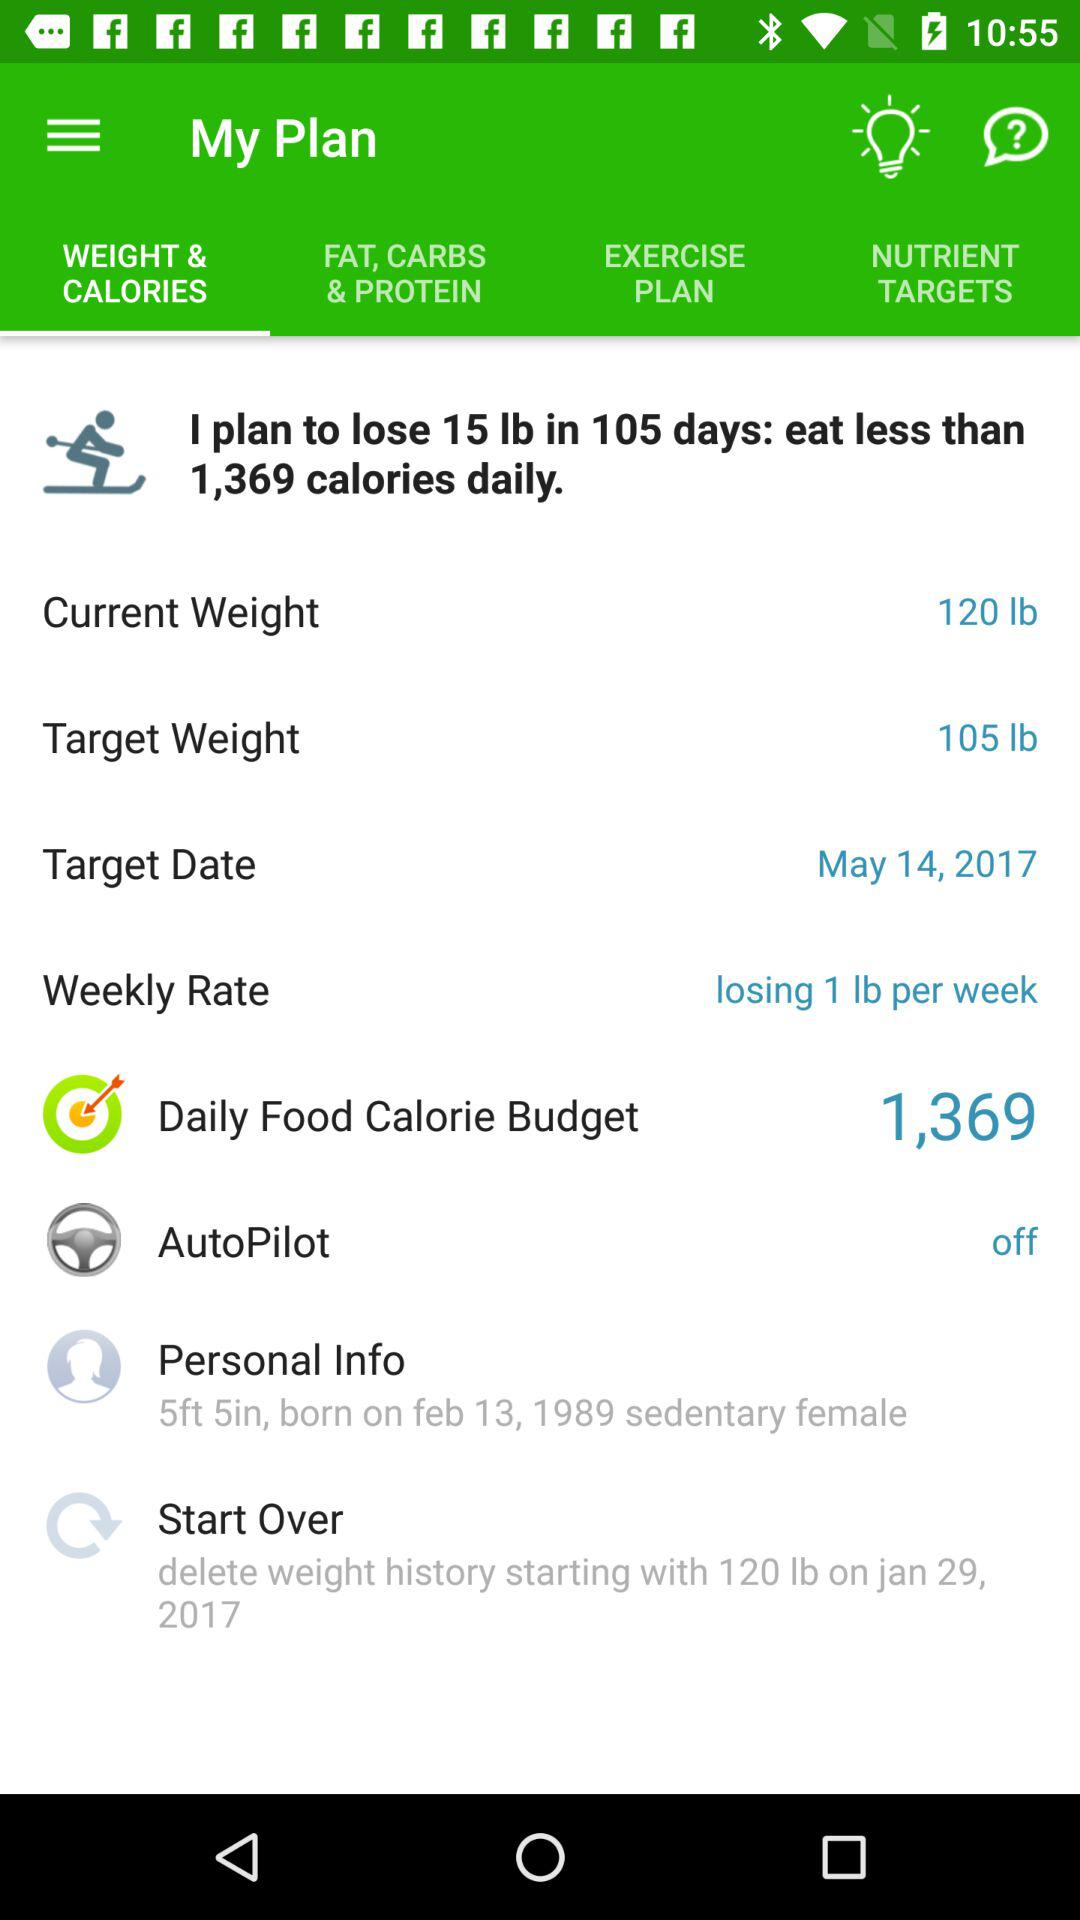What is the current weight? The current weight is 120 lb. 